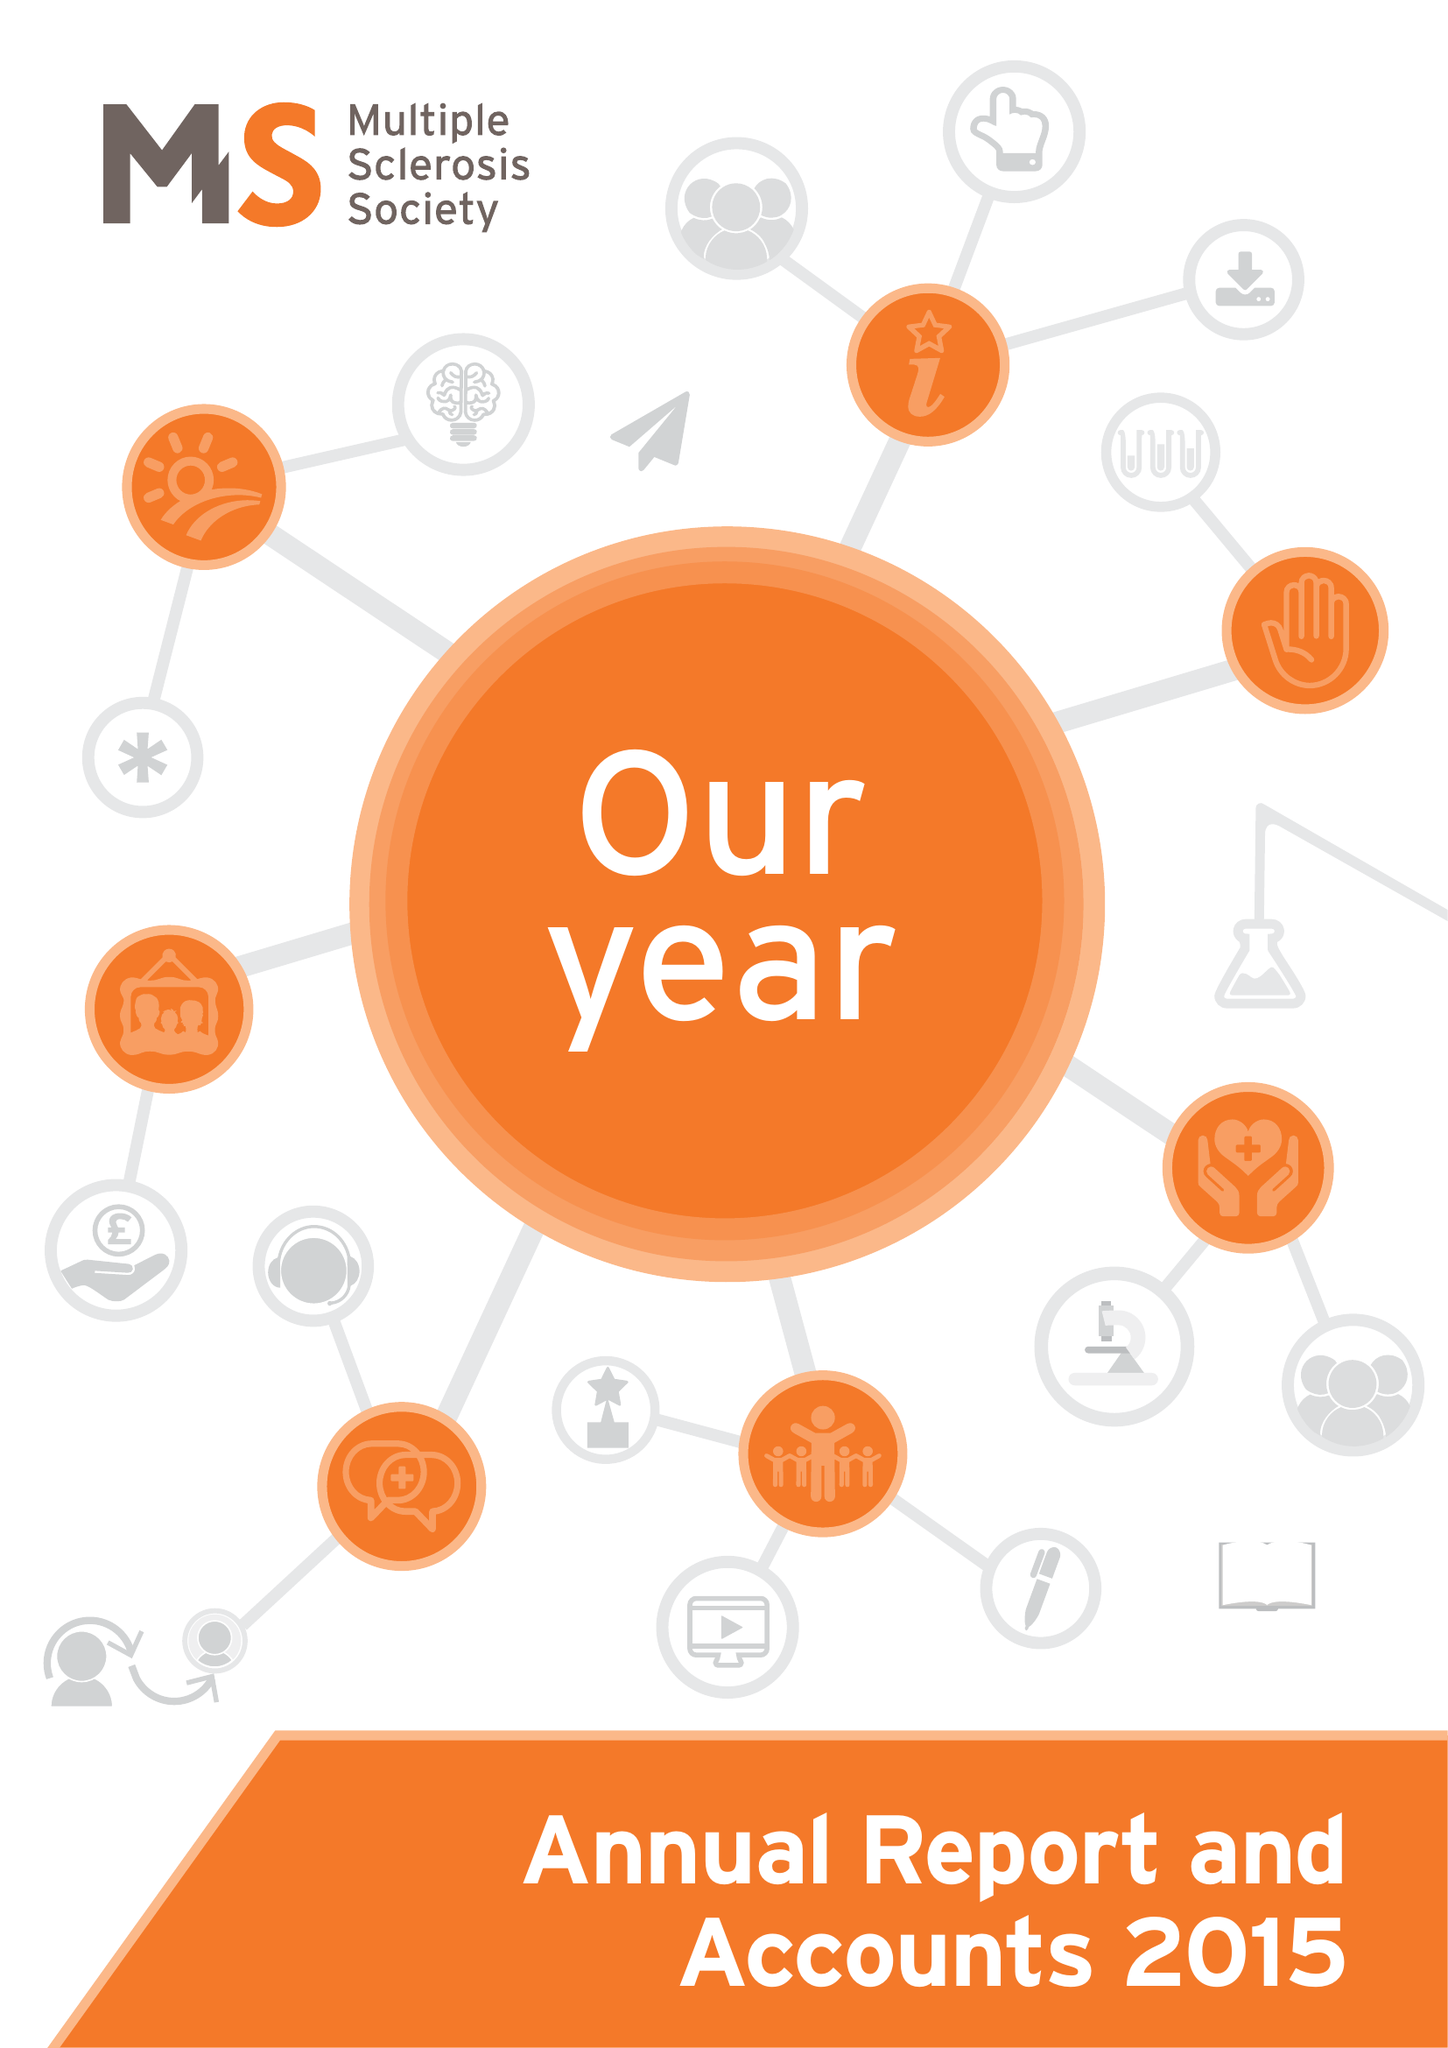What is the value for the spending_annually_in_british_pounds?
Answer the question using a single word or phrase. 27925000.00 